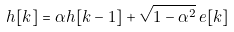Convert formula to latex. <formula><loc_0><loc_0><loc_500><loc_500>h [ k ] = \alpha h [ k - 1 ] + \sqrt { 1 - \alpha ^ { 2 } } \, e [ k ]</formula> 